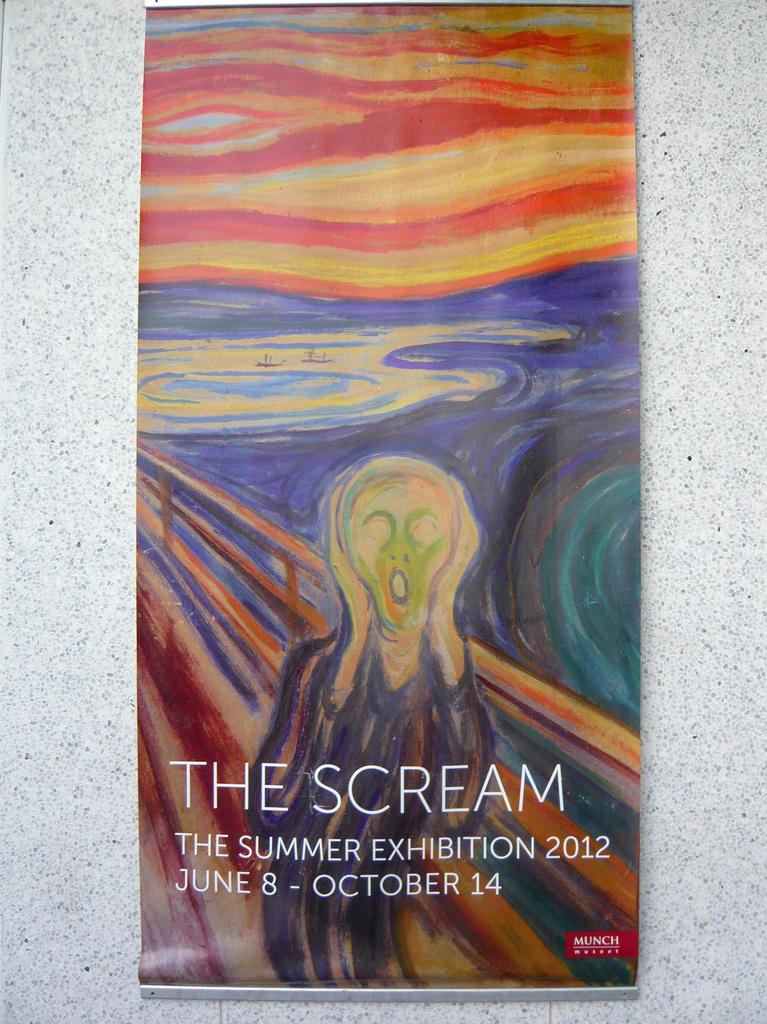What is hanging on the wall in the image? There is a banner on the wall in the image. What is depicted on the banner? The banner contains a depiction of a person. Is there any text on the banner? Yes, the banner contains some text. How many chickens are jumping over the frog in the image? There are no chickens or frogs present in the image; it features a banner with a depiction of a person and some text. 